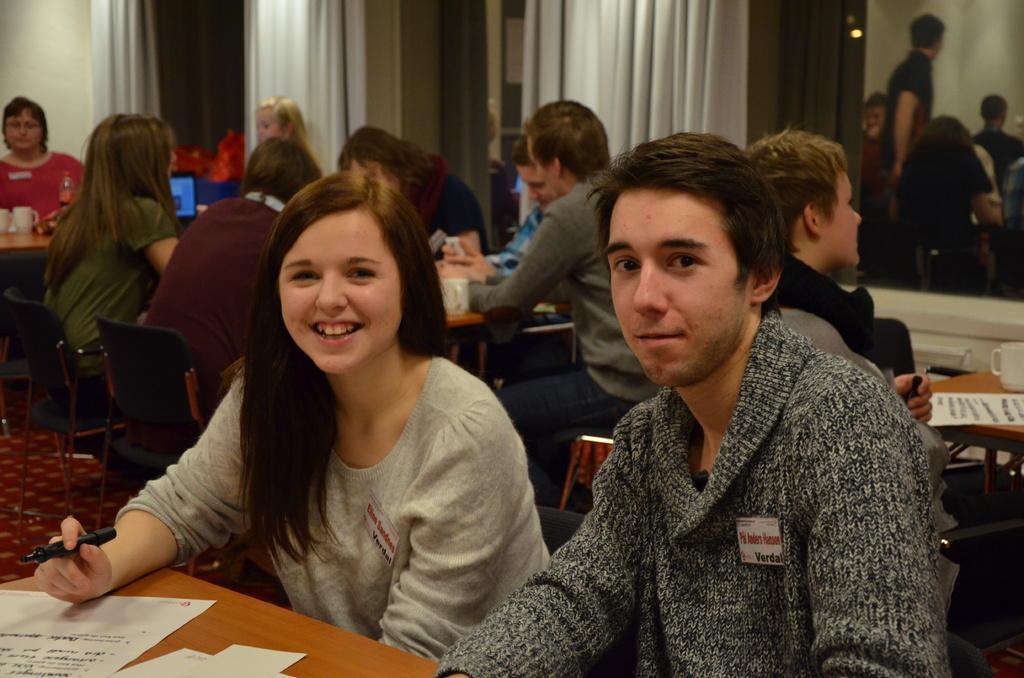In one or two sentences, can you explain what this image depicts? there are many people sitting on the chair with the table in front of them and there are some items present on the table. 